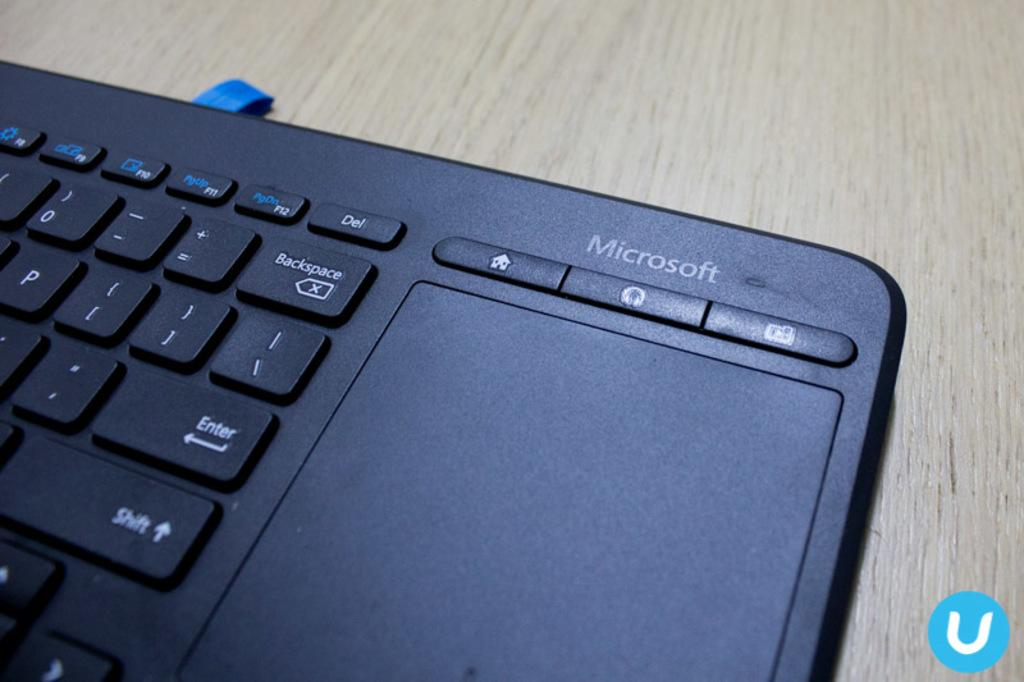<image>
Relay a brief, clear account of the picture shown. The black microsoft table is on the wooden table 